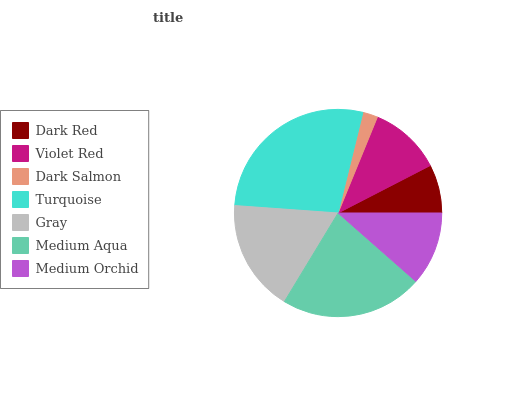Is Dark Salmon the minimum?
Answer yes or no. Yes. Is Turquoise the maximum?
Answer yes or no. Yes. Is Violet Red the minimum?
Answer yes or no. No. Is Violet Red the maximum?
Answer yes or no. No. Is Violet Red greater than Dark Red?
Answer yes or no. Yes. Is Dark Red less than Violet Red?
Answer yes or no. Yes. Is Dark Red greater than Violet Red?
Answer yes or no. No. Is Violet Red less than Dark Red?
Answer yes or no. No. Is Medium Orchid the high median?
Answer yes or no. Yes. Is Medium Orchid the low median?
Answer yes or no. Yes. Is Turquoise the high median?
Answer yes or no. No. Is Turquoise the low median?
Answer yes or no. No. 